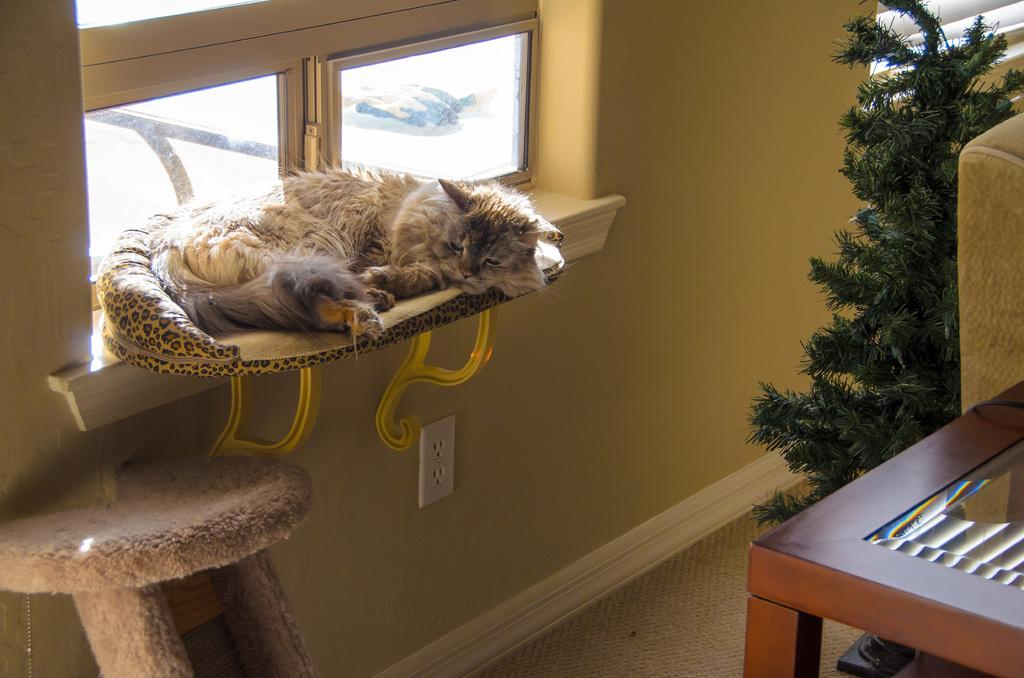What type of animal is present in the image? There is a cat in the image. What is the cat doing in the image? The cat is sleeping. Where is the cat located in the image? The cat is on a cat bed. What type of jam is the cat eating in the image? There is no jam present in the image; the cat is sleeping on a cat bed. 